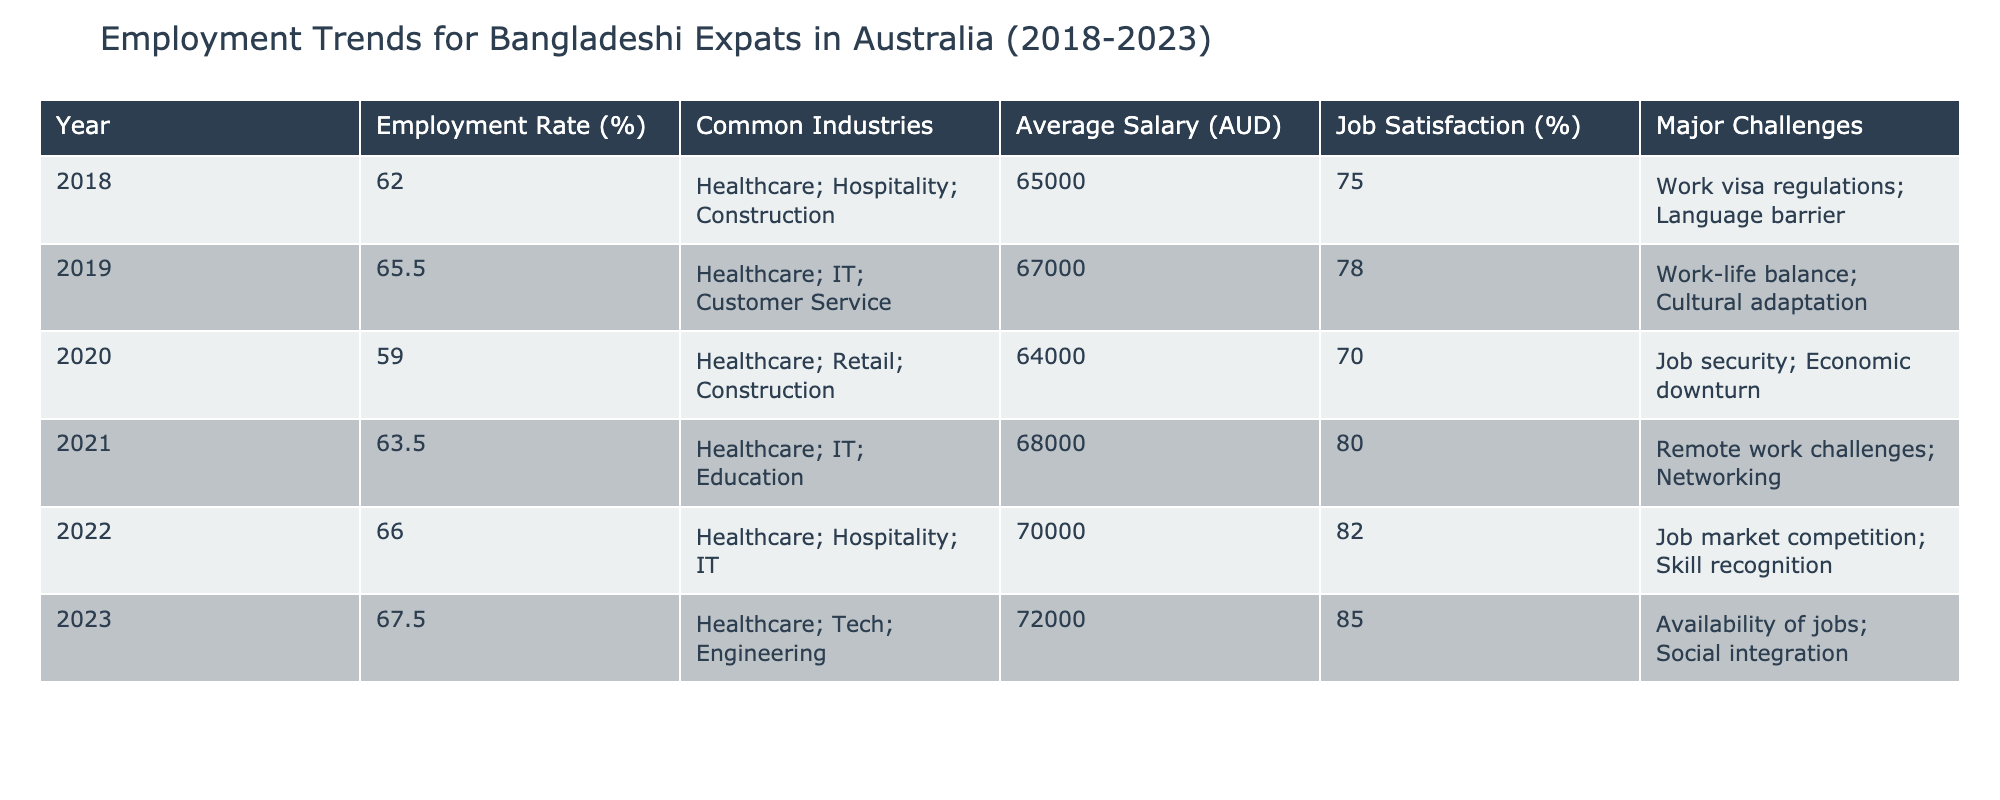What was the employment rate for Bangladeshi expats in Australia in 2020? The table indicates that the employment rate for Bangladeshi expats in Australia in 2020 was listed as 59.0%.
Answer: 59.0% Which year had the highest average salary for Bangladeshi expats? By examining the average salary column, the highest average salary was in 2023, which is 72,000 AUD.
Answer: 72,000 AUD What major challenges did Bangladeshi expats face in 2021? The table shows that in 2021, the major challenges faced were remote work challenges and networking issues.
Answer: Remote work challenges; Networking Did the job satisfaction increase from 2018 to 2023? Looking at the job satisfaction percentages, 2018 had 75% and 2023 had 85%. This indicates an increase.
Answer: Yes What were the common industries for Bangladeshi expats in Australia in 2022? The common industries listed for 2022 include Healthcare, Hospitality, and IT.
Answer: Healthcare; Hospitality; IT Calculate the average employment rate from 2018 to 2023. The employment rates from 2018 to 2023 are 62.0, 65.5, 59.0, 63.5, 66.0, and 67.5. The sum is 404.5, and dividing by 6 gives an average of approximately 67.42%.
Answer: 67.42% Which year saw the biggest change in employment rate compared to the previous year? By checking the employment rate differences, 2020 saw a drop to 59.0% from 65.5% in 2019, which is a decrease of 6.5%.
Answer: 2020 Was there any year where the job satisfaction decreased from the previous year? The job satisfaction percentages show that every year from 2018 to 2023 saw an increase; thus, there was no year with a decrease.
Answer: No How did the common industries for Bangladeshi expats change from 2018 to 2023? In comparing the industries, we see a consistent presence of Healthcare, but other industries changed; for instance, IT entered the list in 2019 and stayed, while Construction was more prominent initially.
Answer: Changed with Healthcare remaining consistent What was the difference in average salary between 2019 and 2022? The average salary in 2019 was 67,000 AUD, and in 2022 it was 70,000 AUD. The difference is 70,000 - 67,000 = 3,000 AUD.
Answer: 3,000 AUD 